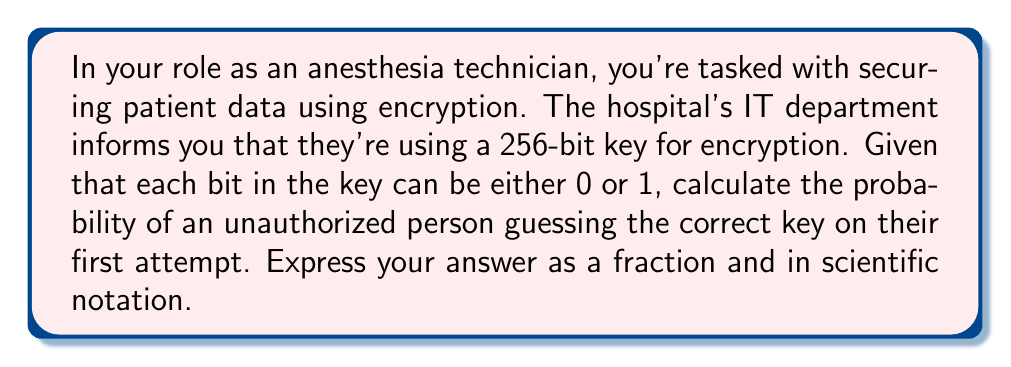What is the answer to this math problem? Let's approach this step-by-step:

1) First, we need to understand what a 256-bit key means:
   - Each bit can be either 0 or 1
   - There are 256 bits in total

2) To calculate the total number of possible keys:
   - For each bit, there are 2 possibilities
   - For 256 bits, we have $2^{256}$ possible combinations

3) The probability of guessing the correct key is:
   $$P(\text{correct guess}) = \frac{1}{\text{total number of possible keys}}$$

4) Substituting our value:
   $$P(\text{correct guess}) = \frac{1}{2^{256}}$$

5) This fraction can be expressed in scientific notation as:
   $$\frac{1}{2^{256}} = 1.158 \times 10^{-77}$$

This extremely small probability demonstrates why 256-bit encryption is considered very secure, much like how precise dosage calculations are crucial in anesthesia to ensure patient safety.
Answer: $\frac{1}{2^{256}}$ or $1.158 \times 10^{-77}$ 